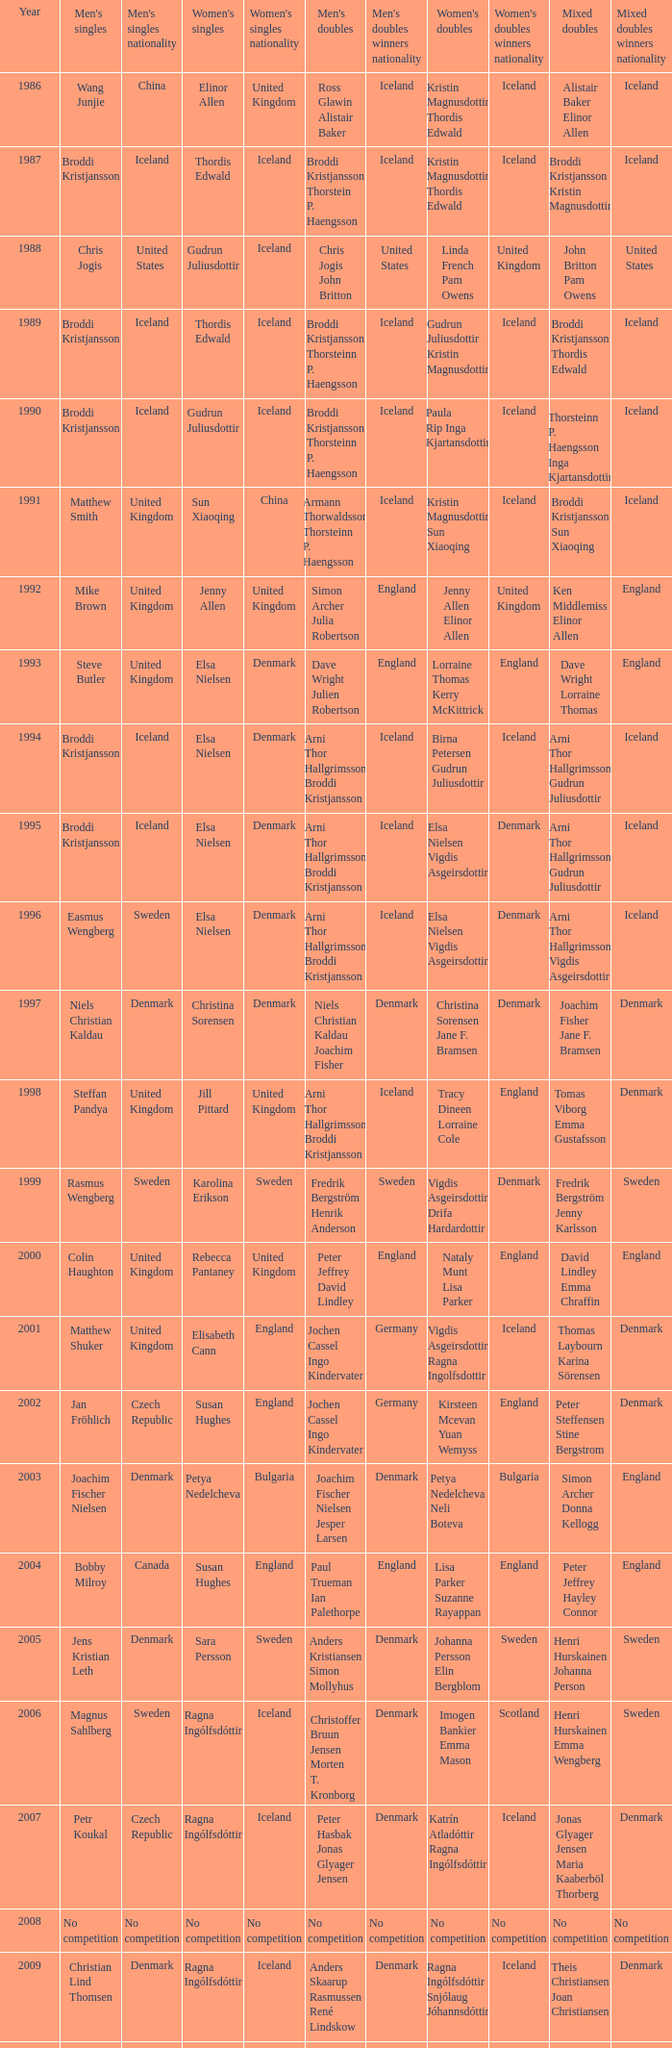In what mixed doubles did Niels Christian Kaldau play in men's singles? Joachim Fisher Jane F. Bramsen. 